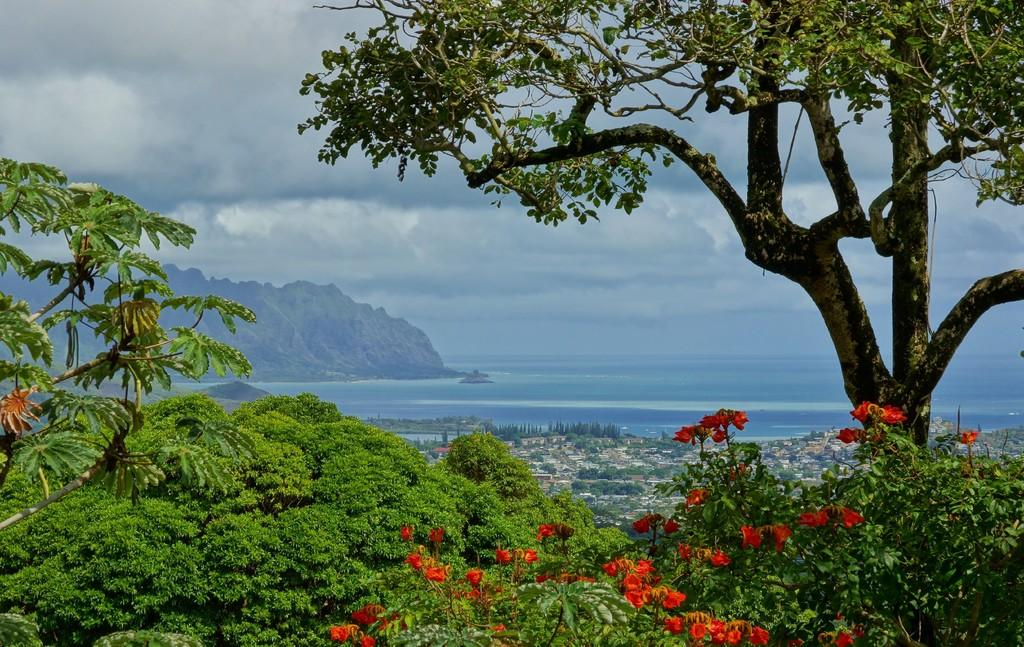What type of plants can be seen in the image? There are flowering plants in the image. What geographical feature is visible in the image? There is a hill visible in the image. What surrounds the hill in the image? There are trees surrounding the hill in the image. What can be seen in the sky in the image? There are clouds in the sky in the image. Is there a drain visible in the image? There is no drain present in the image. What type of garden can be seen in the image? The image does not show a garden; it features flowering plants, a hill, trees, and clouds in the sky. 